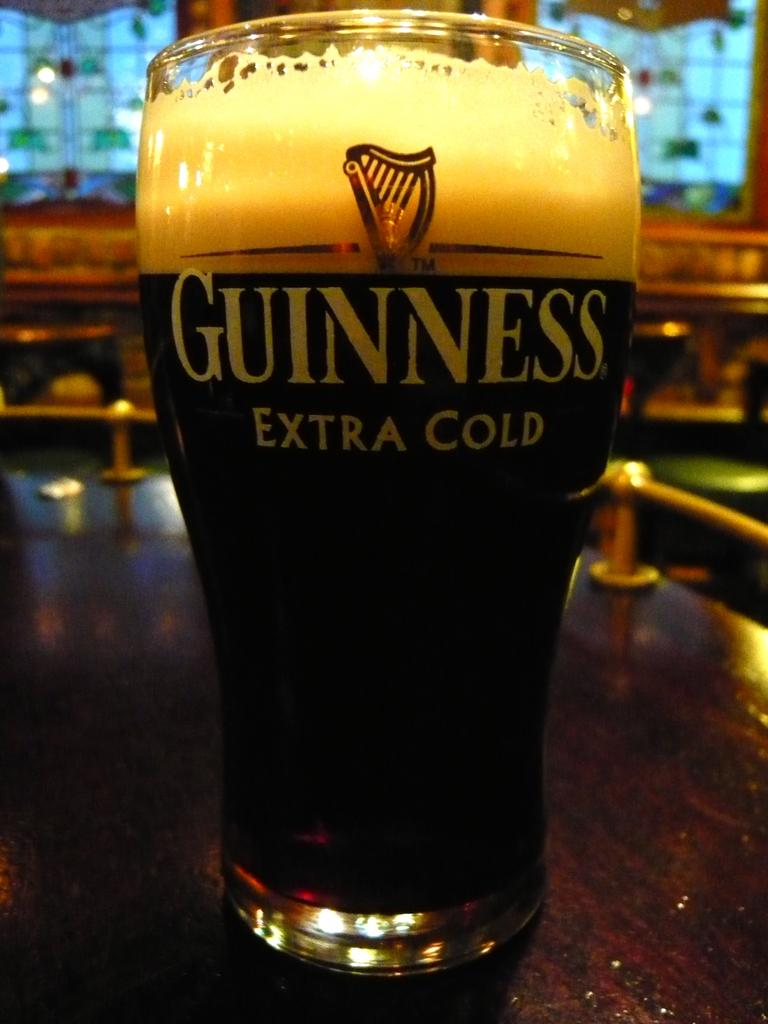What is inside the glass that is visible in the image? There is a liquid inside the glass. Is there any text or design on the glass? Yes, there is writing on the glass. Where is the glass located in the image? The glass is on a table. Can you describe the background of the image? The background of the image is blurred. What type of oven is visible in the image? There is no oven present in the image. How many times does the glass get smashed in the image? The glass does not get smashed in the image; it is stationary on the table. 